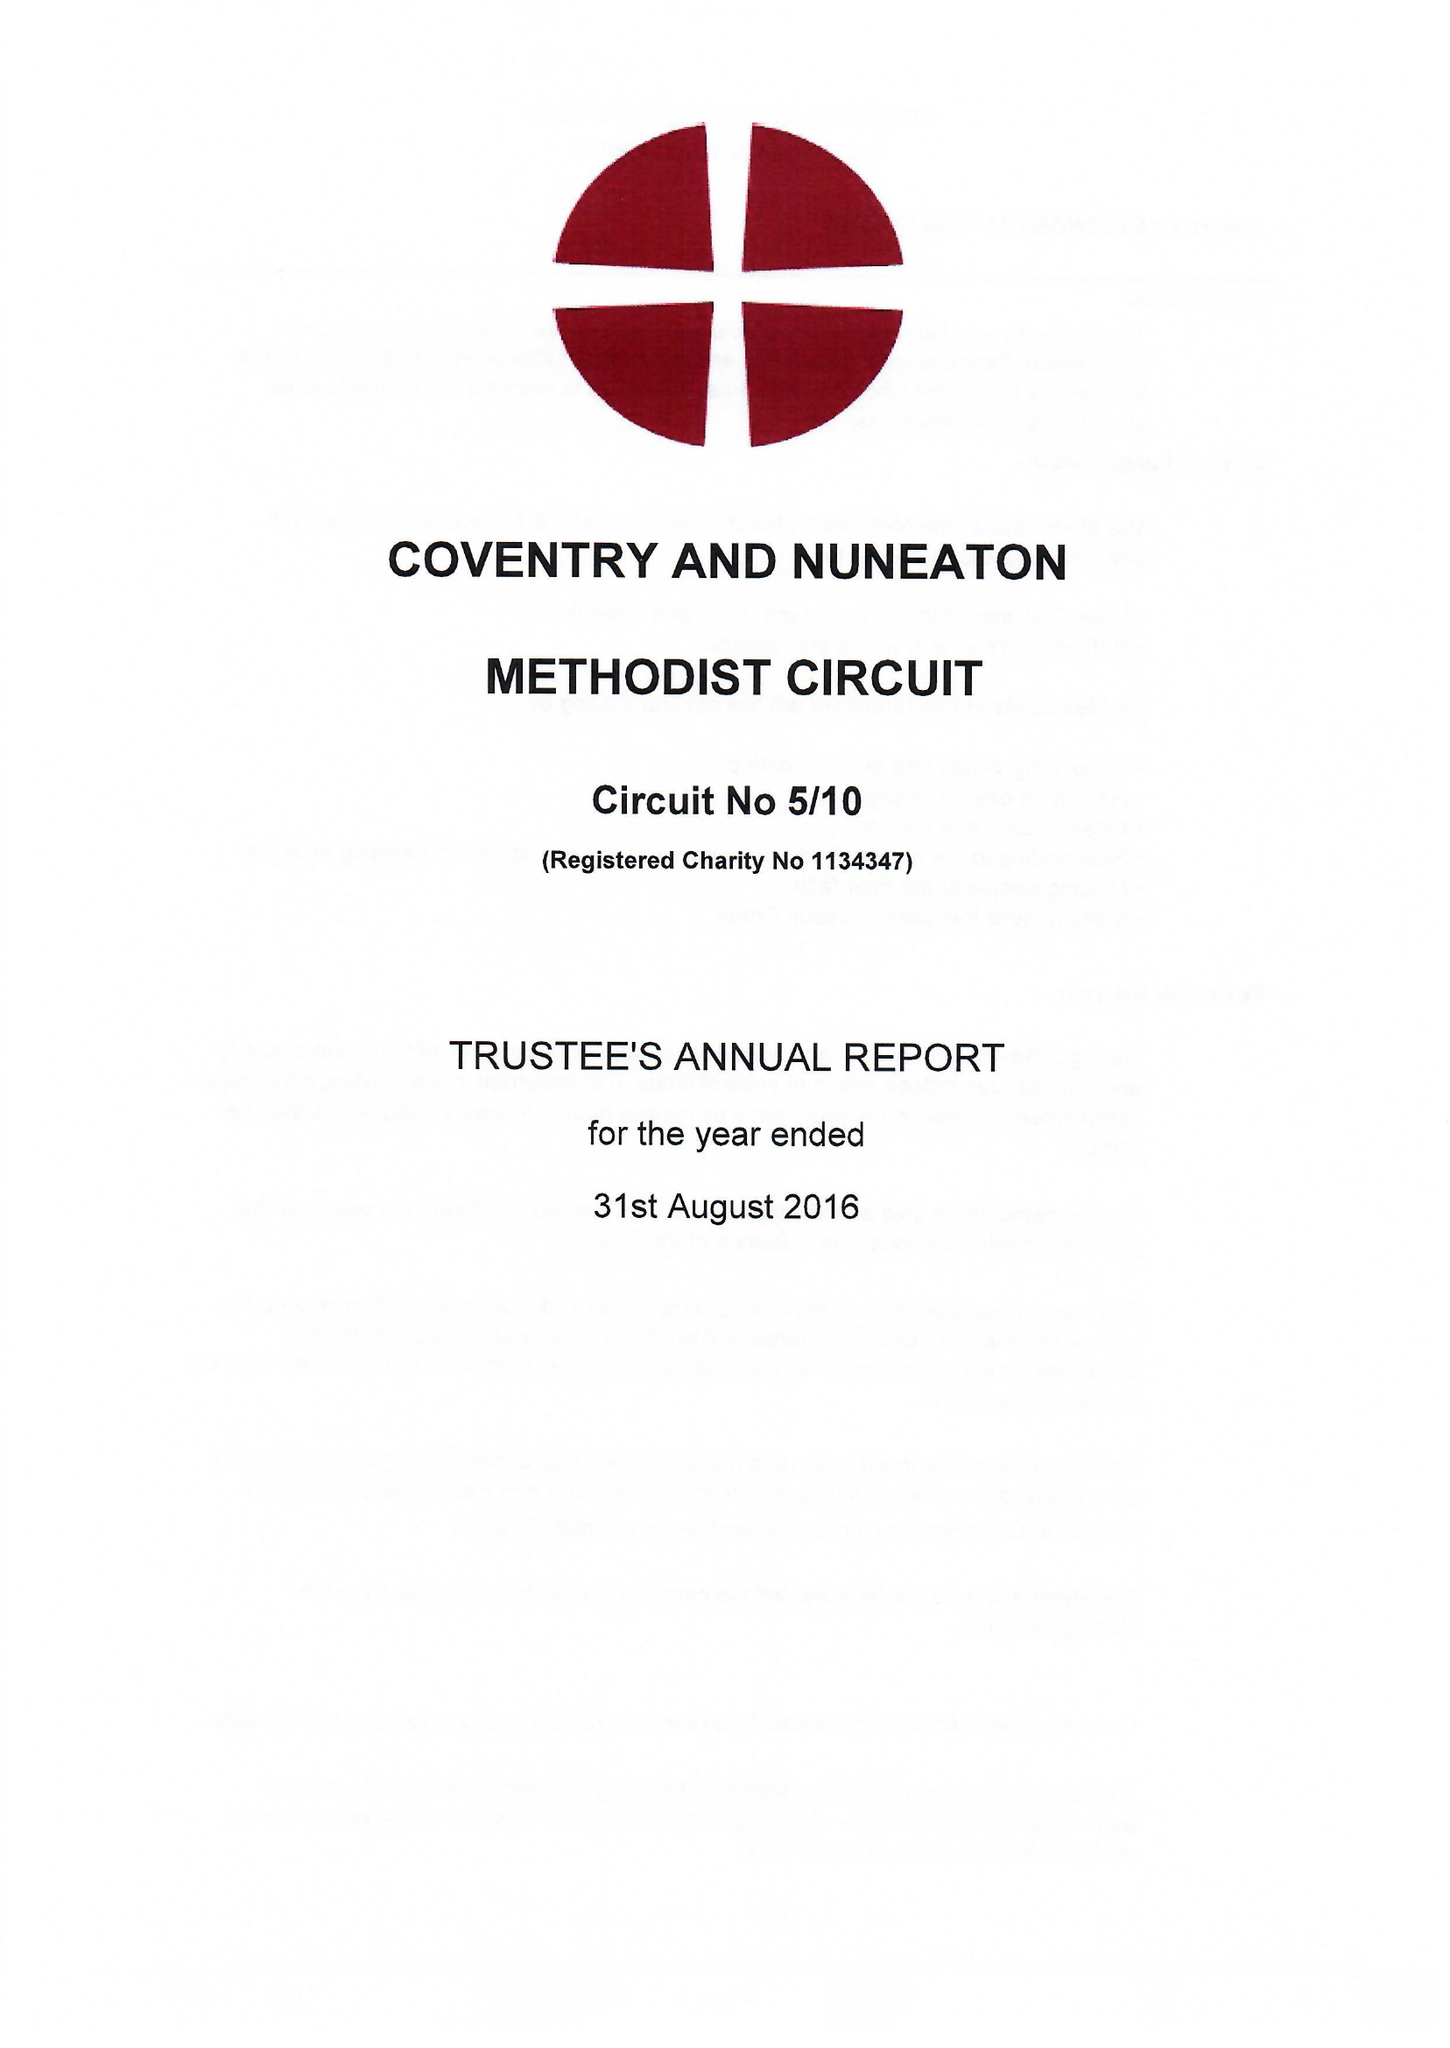What is the value for the income_annually_in_british_pounds?
Answer the question using a single word or phrase. 533823.00 